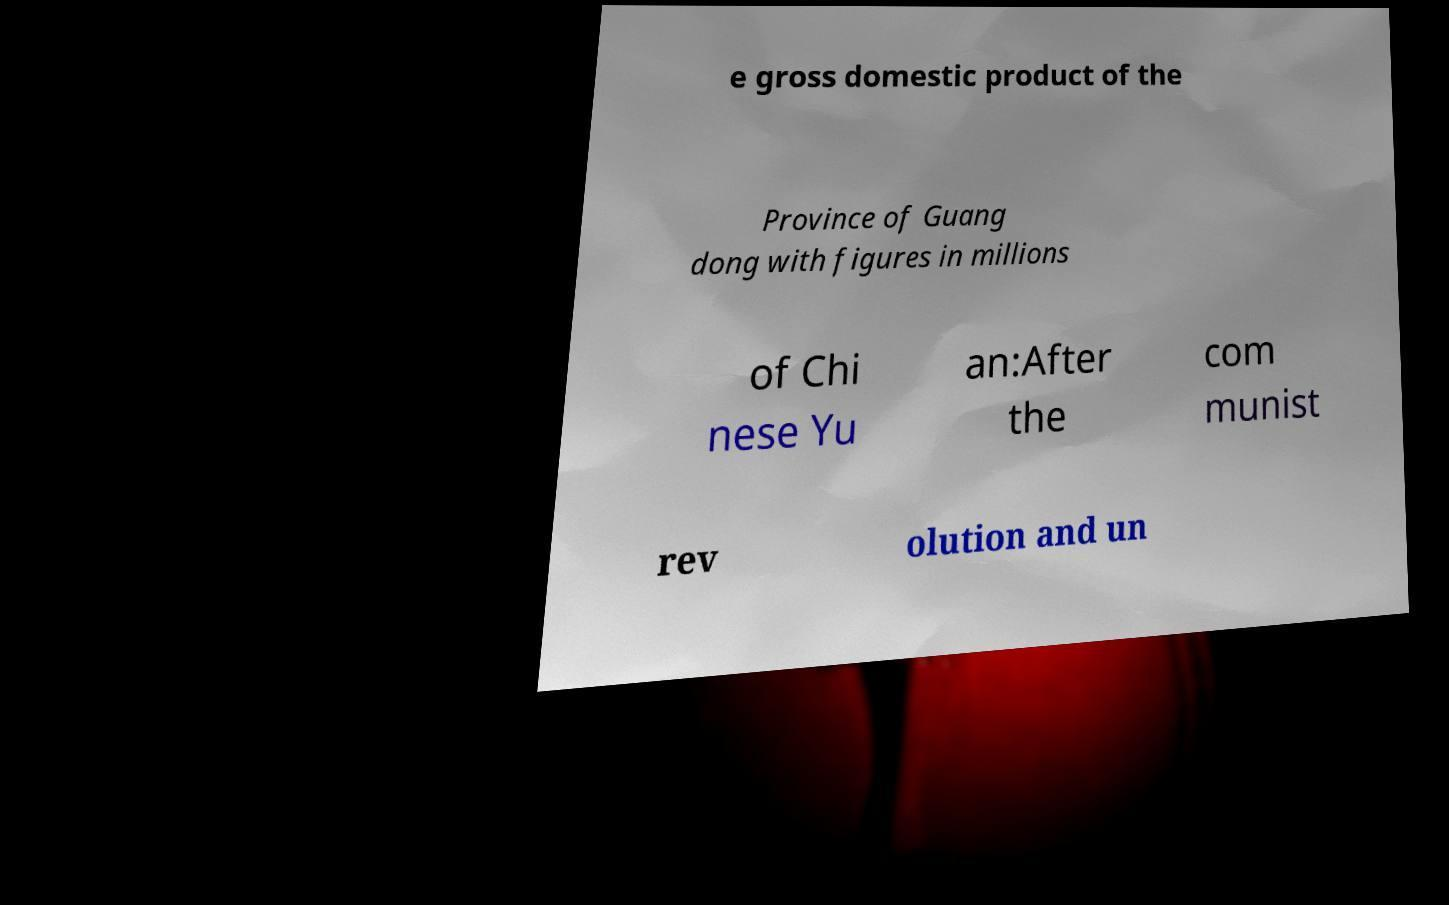Please identify and transcribe the text found in this image. e gross domestic product of the Province of Guang dong with figures in millions of Chi nese Yu an:After the com munist rev olution and un 